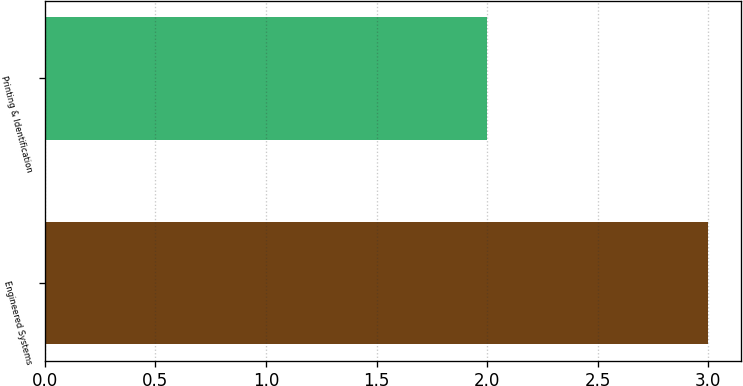Convert chart to OTSL. <chart><loc_0><loc_0><loc_500><loc_500><bar_chart><fcel>Engineered Systems<fcel>Printing & Identification<nl><fcel>3<fcel>2<nl></chart> 